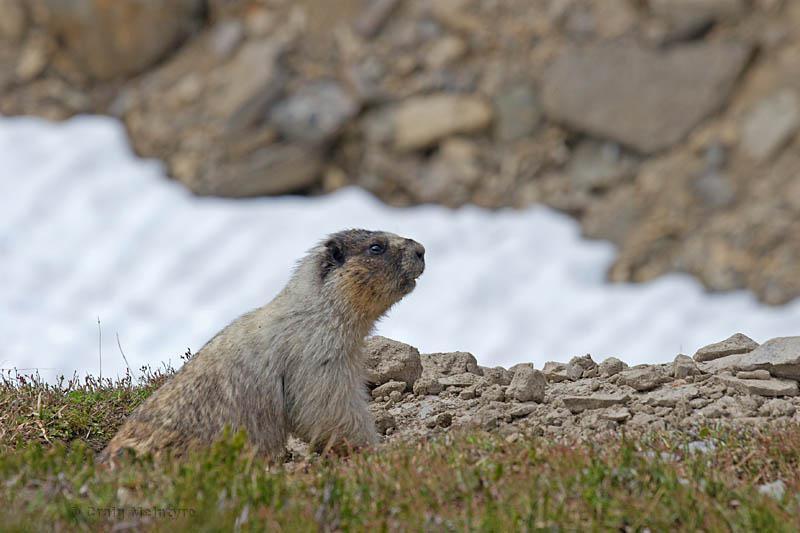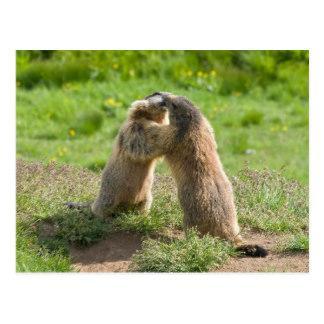The first image is the image on the left, the second image is the image on the right. Given the left and right images, does the statement "The left image contains two rodents that are face to face." hold true? Answer yes or no. No. The first image is the image on the left, the second image is the image on the right. Assess this claim about the two images: "Two marmots are standing with arms around one another and noses touching, in a pose that looks like dancing.". Correct or not? Answer yes or no. Yes. 